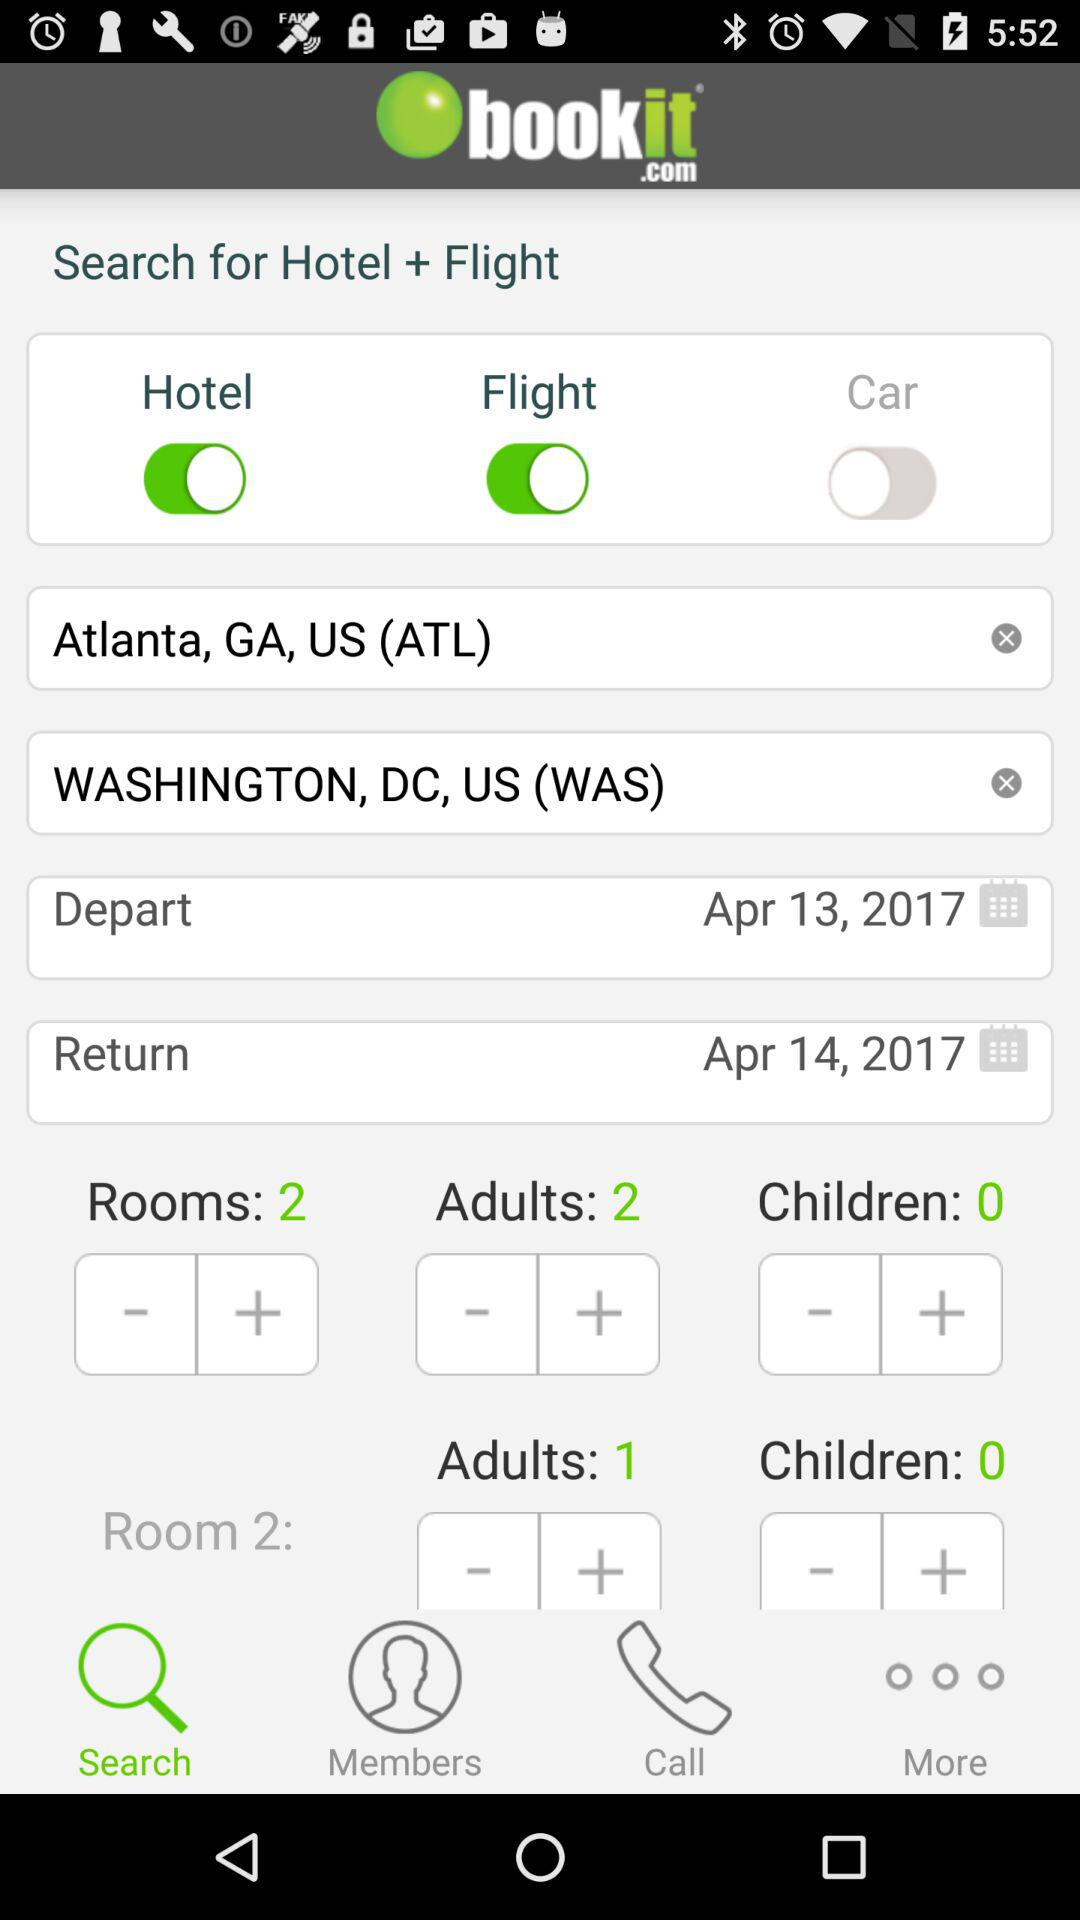What is the current status of the "Flight"? The current status of the Flight is "on". 